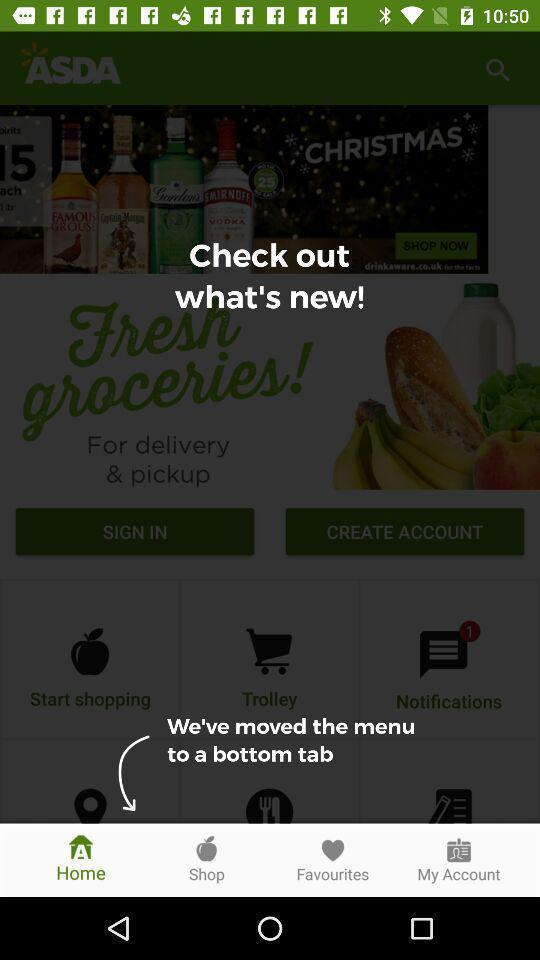Provide a textual representation of this image. Page showing directions in a shopping app. 